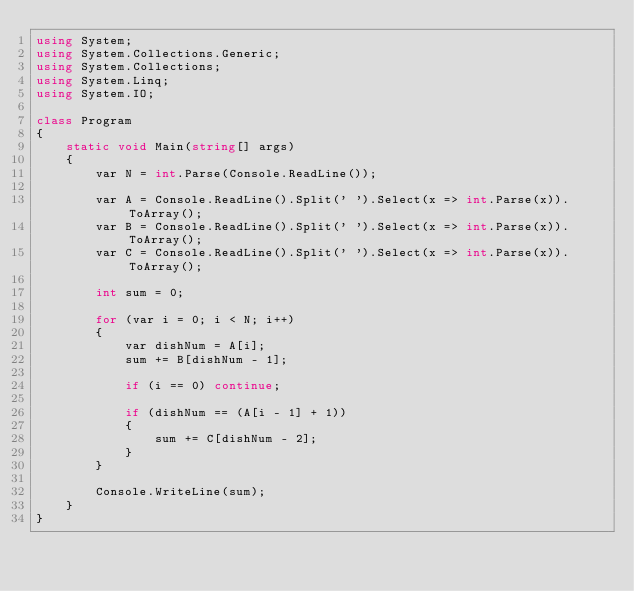Convert code to text. <code><loc_0><loc_0><loc_500><loc_500><_C#_>using System;
using System.Collections.Generic;
using System.Collections;
using System.Linq;
using System.IO;

class Program
{
    static void Main(string[] args)
    {
        var N = int.Parse(Console.ReadLine());

        var A = Console.ReadLine().Split(' ').Select(x => int.Parse(x)).ToArray();
        var B = Console.ReadLine().Split(' ').Select(x => int.Parse(x)).ToArray();
        var C = Console.ReadLine().Split(' ').Select(x => int.Parse(x)).ToArray();

        int sum = 0;

        for (var i = 0; i < N; i++)
        {
            var dishNum = A[i];
            sum += B[dishNum - 1];

            if (i == 0) continue;

            if (dishNum == (A[i - 1] + 1))
            {
                sum += C[dishNum - 2];
            }
        }

        Console.WriteLine(sum);
    }
}</code> 